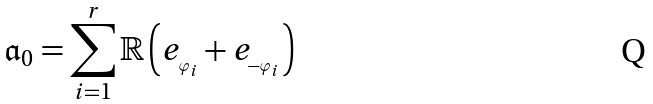Convert formula to latex. <formula><loc_0><loc_0><loc_500><loc_500>\mathfrak { a } _ { 0 } = \sum _ { i = 1 } ^ { r } \mathbb { R } \left ( e _ { _ { \varphi _ { i } } } + e _ { _ { - \varphi _ { i } } } \right )</formula> 